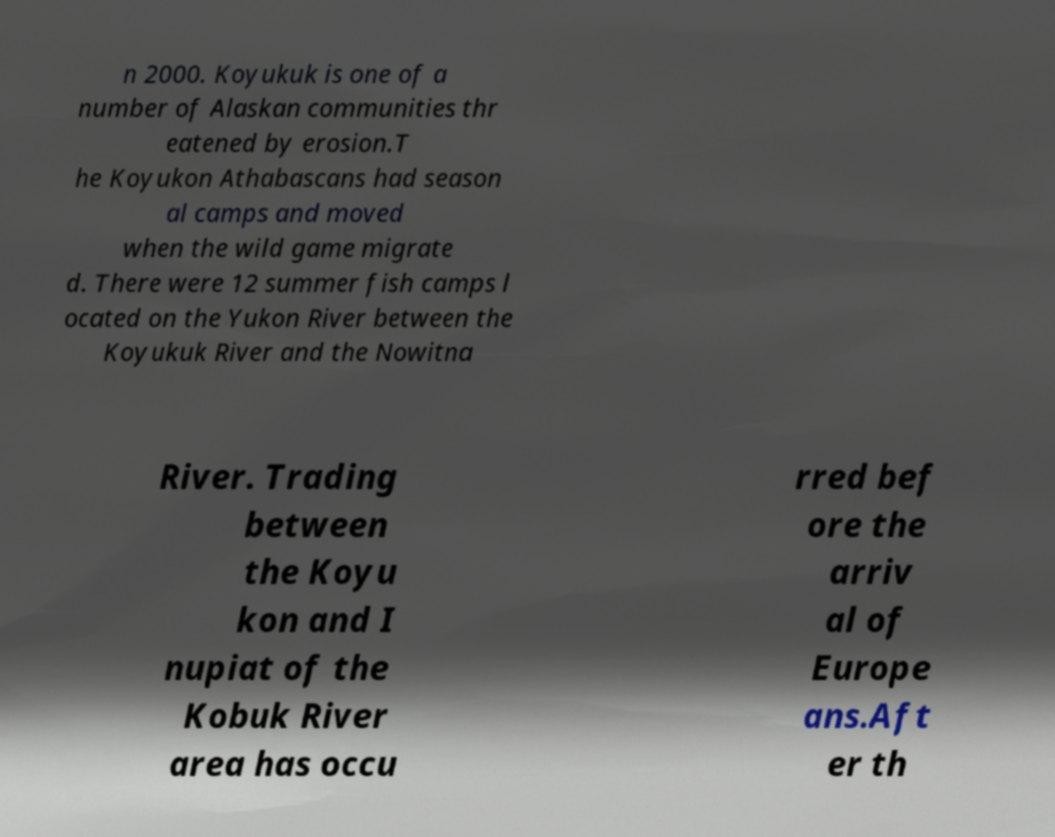Could you extract and type out the text from this image? n 2000. Koyukuk is one of a number of Alaskan communities thr eatened by erosion.T he Koyukon Athabascans had season al camps and moved when the wild game migrate d. There were 12 summer fish camps l ocated on the Yukon River between the Koyukuk River and the Nowitna River. Trading between the Koyu kon and I nupiat of the Kobuk River area has occu rred bef ore the arriv al of Europe ans.Aft er th 